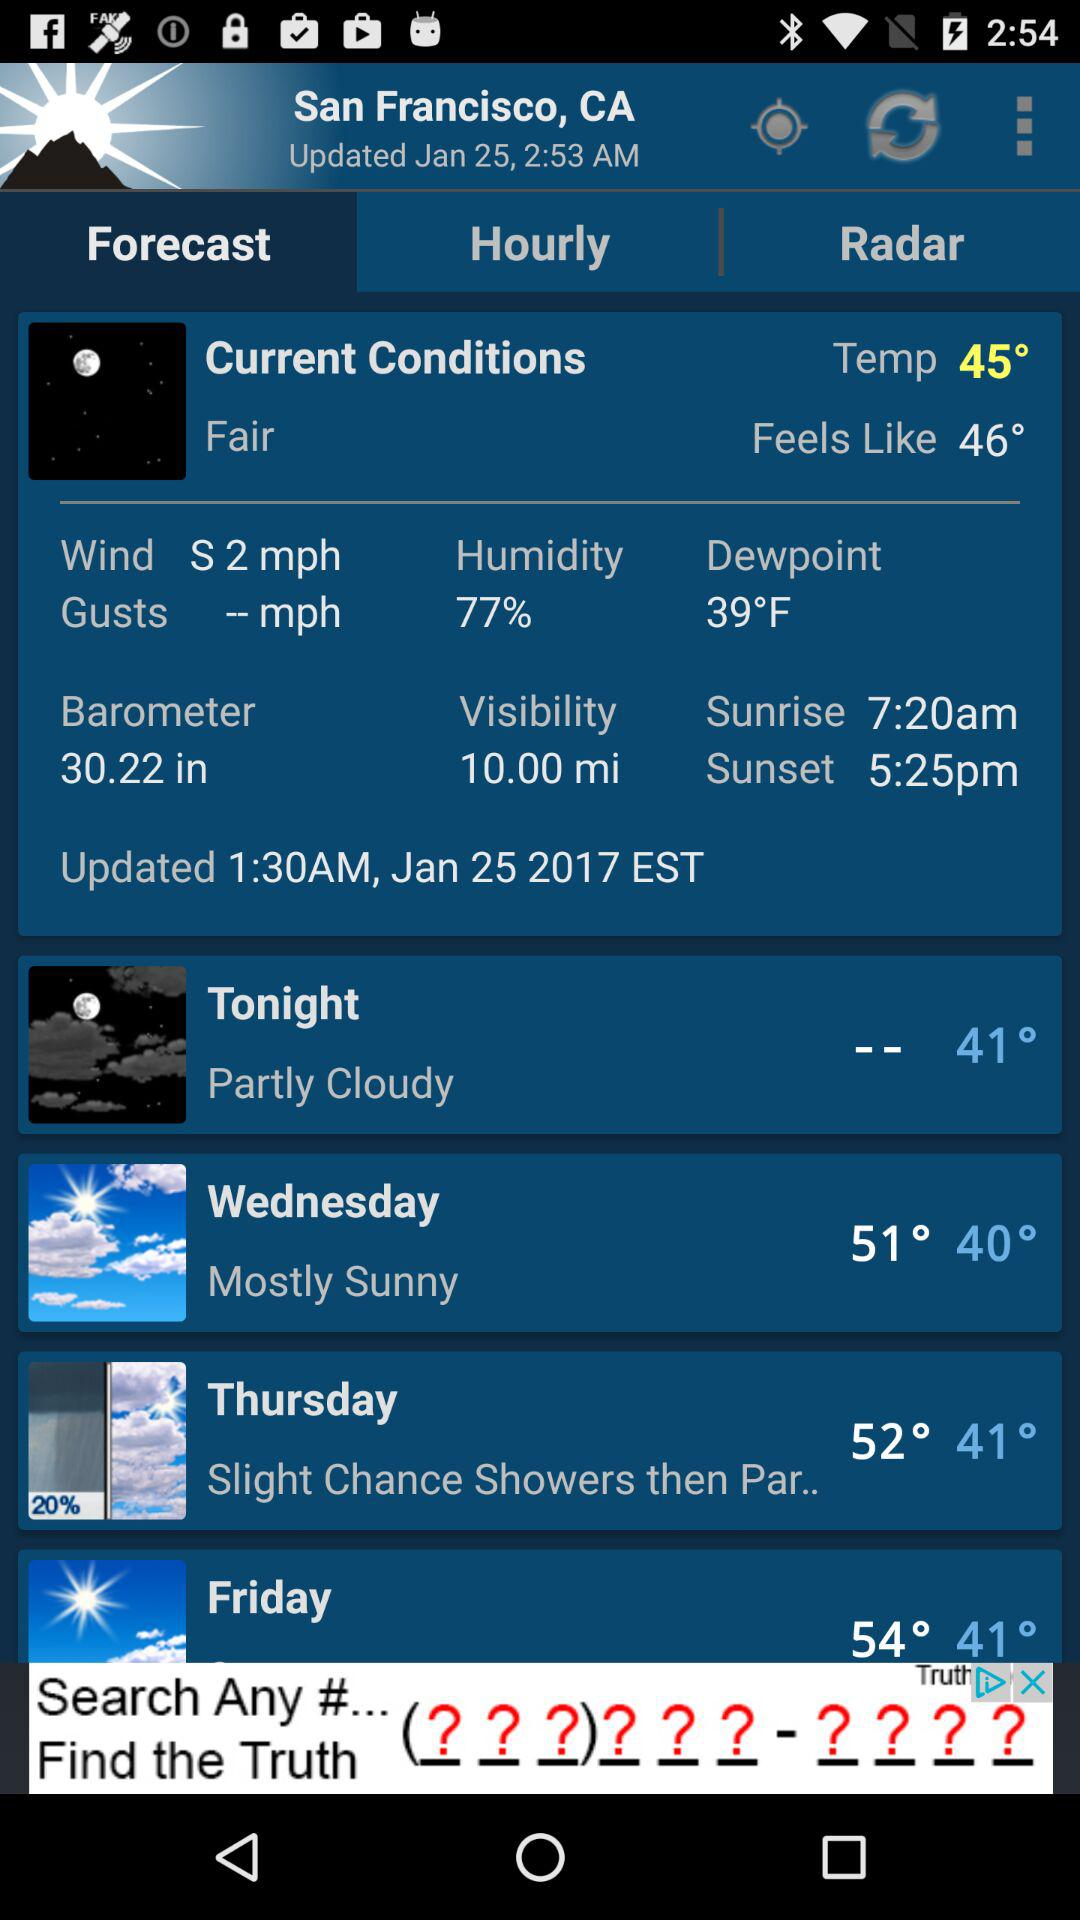What is the weather forecast for Thursday? The weather forecast for Thursday is "Slight Chance Showers then Par..". 